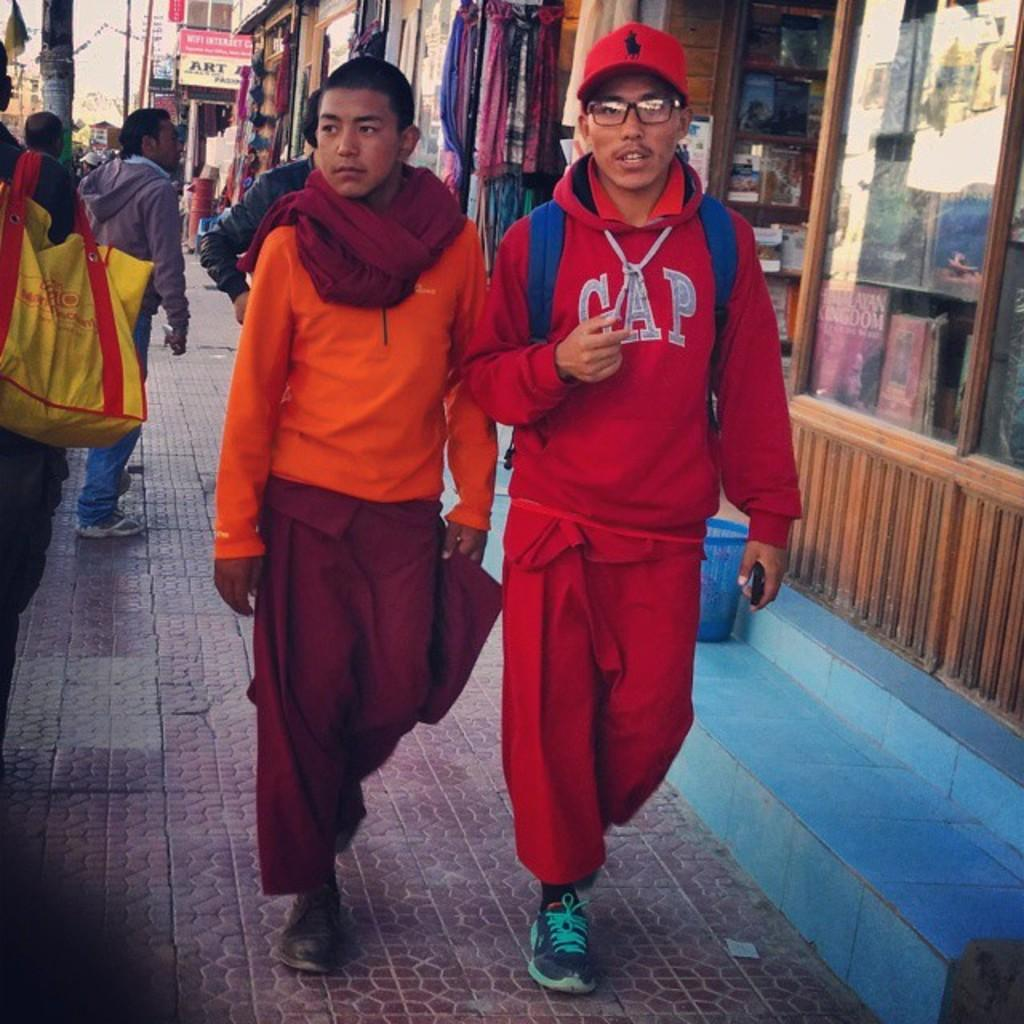How many people are in the image? There are people in the image, but the exact number is not specified. What are some people holding in the image? Some people are holding bags in the image. What can be seen in the background of the image? In the background, there are buildings, stores, boards, poles, and wires. What might the people be doing in the image? Based on the presence of bags, the people might be shopping or carrying items. What type of pot is being used to cover the wires in the image? There is no pot present in the image, and the wires are not covered. 